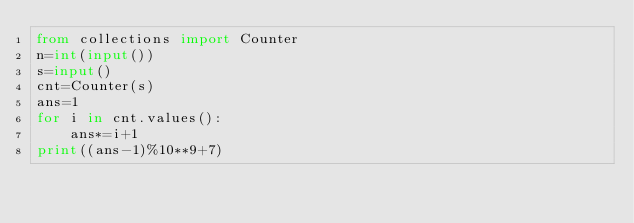Convert code to text. <code><loc_0><loc_0><loc_500><loc_500><_Python_>from collections import Counter
n=int(input())
s=input()
cnt=Counter(s)
ans=1
for i in cnt.values():
    ans*=i+1
print((ans-1)%10**9+7)</code> 